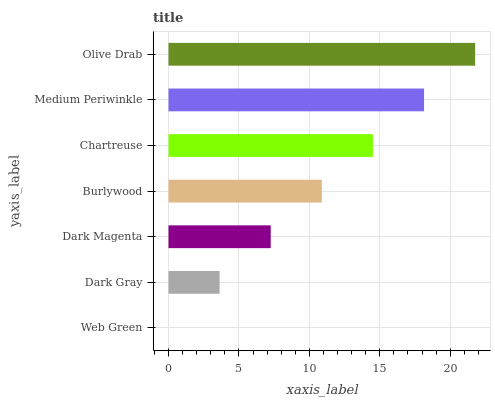Is Web Green the minimum?
Answer yes or no. Yes. Is Olive Drab the maximum?
Answer yes or no. Yes. Is Dark Gray the minimum?
Answer yes or no. No. Is Dark Gray the maximum?
Answer yes or no. No. Is Dark Gray greater than Web Green?
Answer yes or no. Yes. Is Web Green less than Dark Gray?
Answer yes or no. Yes. Is Web Green greater than Dark Gray?
Answer yes or no. No. Is Dark Gray less than Web Green?
Answer yes or no. No. Is Burlywood the high median?
Answer yes or no. Yes. Is Burlywood the low median?
Answer yes or no. Yes. Is Dark Gray the high median?
Answer yes or no. No. Is Dark Magenta the low median?
Answer yes or no. No. 